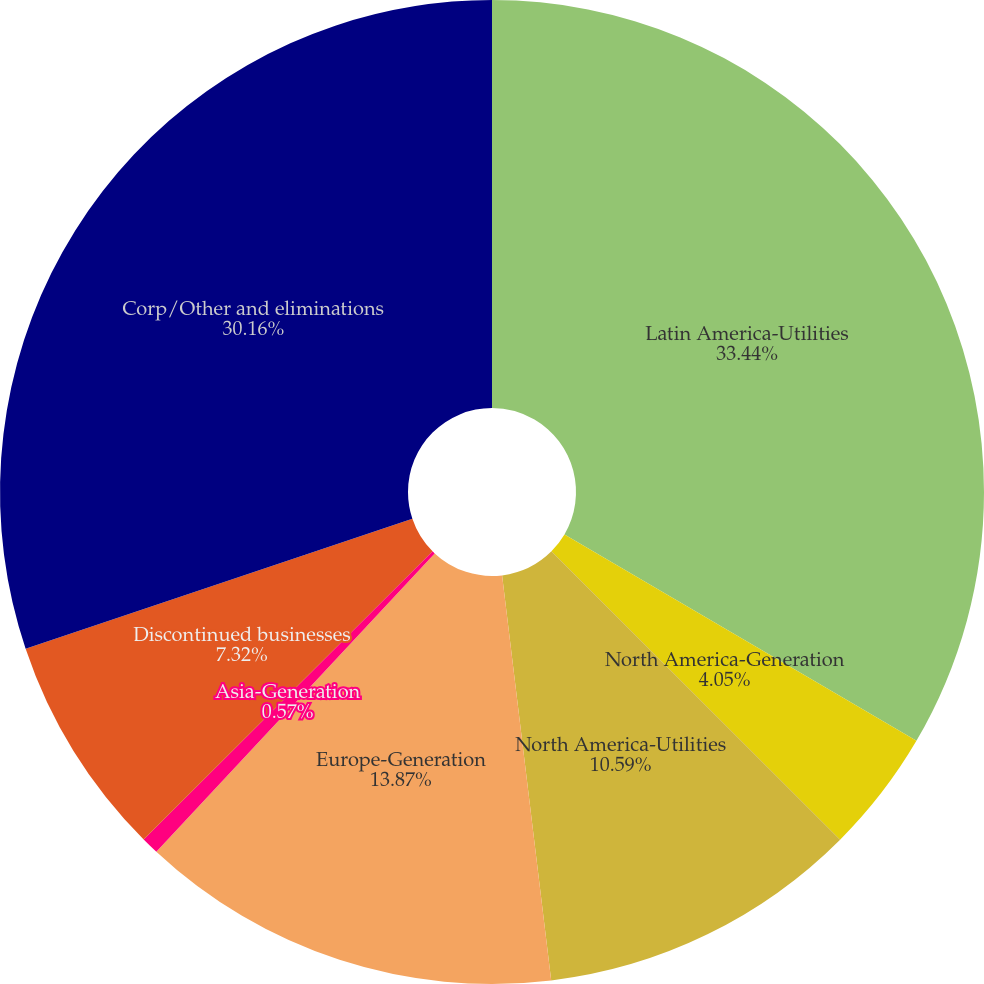<chart> <loc_0><loc_0><loc_500><loc_500><pie_chart><fcel>Latin America-Utilities<fcel>North America-Generation<fcel>North America-Utilities<fcel>Europe-Generation<fcel>Asia-Generation<fcel>Discontinued businesses<fcel>Corp/Other and eliminations<nl><fcel>33.44%<fcel>4.05%<fcel>10.59%<fcel>13.87%<fcel>0.57%<fcel>7.32%<fcel>30.16%<nl></chart> 